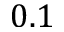<formula> <loc_0><loc_0><loc_500><loc_500>0 . 1</formula> 